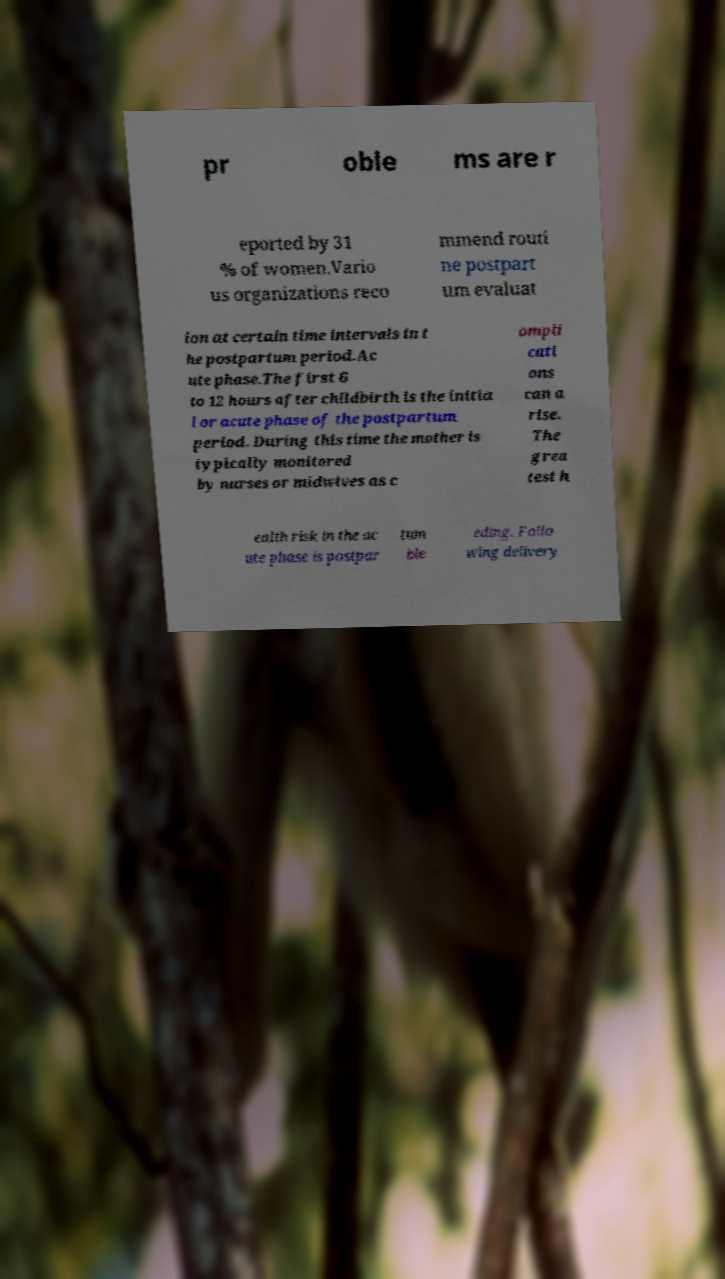I need the written content from this picture converted into text. Can you do that? pr oble ms are r eported by 31 % of women.Vario us organizations reco mmend routi ne postpart um evaluat ion at certain time intervals in t he postpartum period.Ac ute phase.The first 6 to 12 hours after childbirth is the initia l or acute phase of the postpartum period. During this time the mother is typically monitored by nurses or midwives as c ompli cati ons can a rise. The grea test h ealth risk in the ac ute phase is postpar tum ble eding. Follo wing delivery 